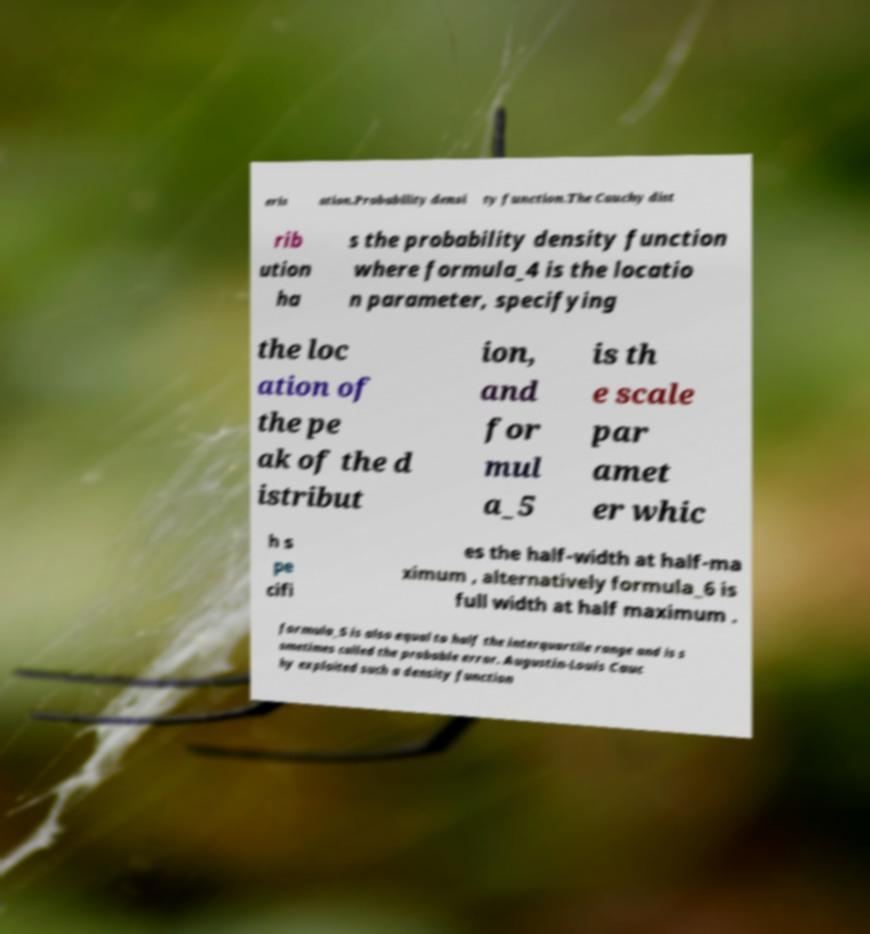Can you read and provide the text displayed in the image?This photo seems to have some interesting text. Can you extract and type it out for me? eris ation.Probability densi ty function.The Cauchy dist rib ution ha s the probability density function where formula_4 is the locatio n parameter, specifying the loc ation of the pe ak of the d istribut ion, and for mul a_5 is th e scale par amet er whic h s pe cifi es the half-width at half-ma ximum , alternatively formula_6 is full width at half maximum . formula_5 is also equal to half the interquartile range and is s ometimes called the probable error. Augustin-Louis Cauc hy exploited such a density function 